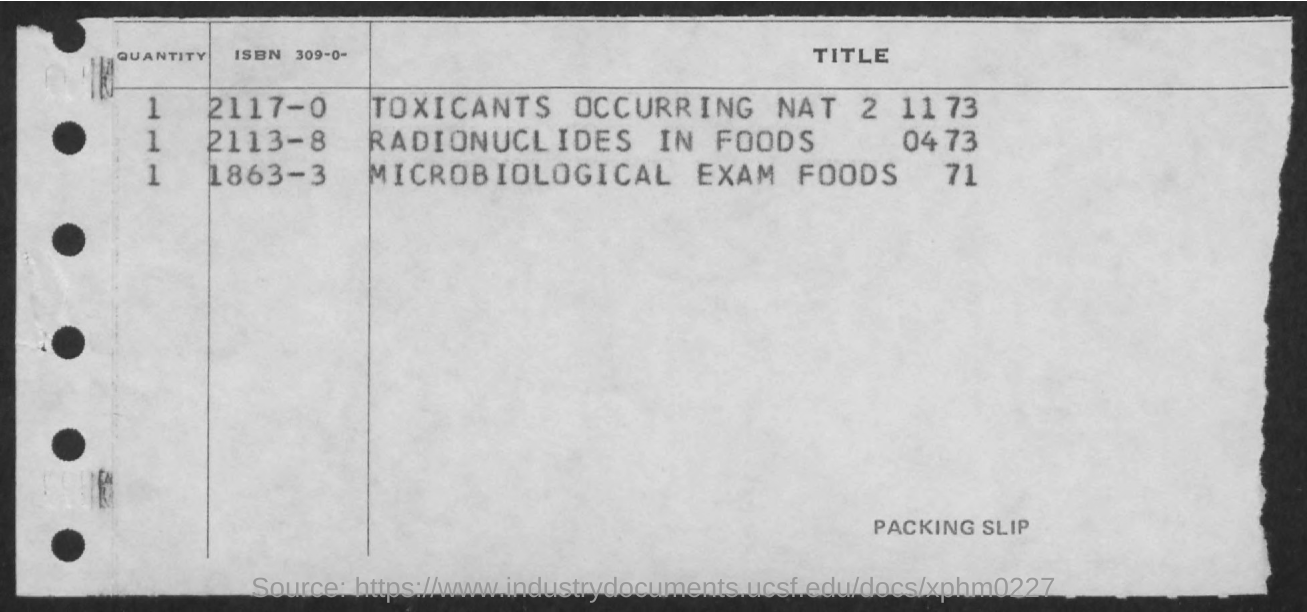What is the heading of the first column?
Make the answer very short. Quantity. What is the title for ISBN 2117-0?
Provide a succinct answer. Toxicants occuring NAT 2 11 73. What type slip is it?
Your response must be concise. Packing slip. 